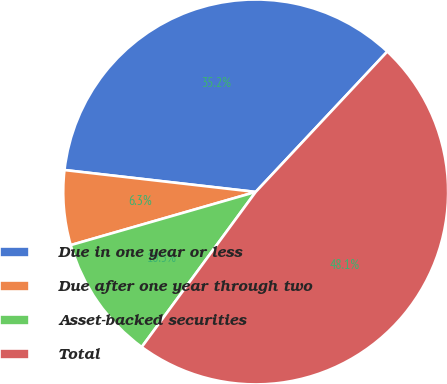Convert chart to OTSL. <chart><loc_0><loc_0><loc_500><loc_500><pie_chart><fcel>Due in one year or less<fcel>Due after one year through two<fcel>Asset-backed securities<fcel>Total<nl><fcel>35.17%<fcel>6.27%<fcel>10.46%<fcel>48.1%<nl></chart> 